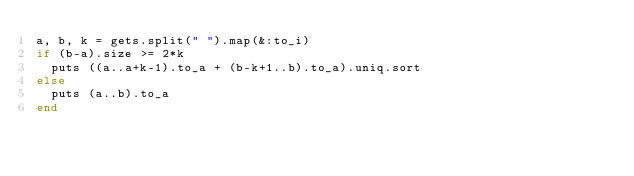Convert code to text. <code><loc_0><loc_0><loc_500><loc_500><_Ruby_>a, b, k = gets.split(" ").map(&:to_i)
if (b-a).size >= 2*k
  puts ((a..a+k-1).to_a + (b-k+1..b).to_a).uniq.sort
else
  puts (a..b).to_a
end
</code> 